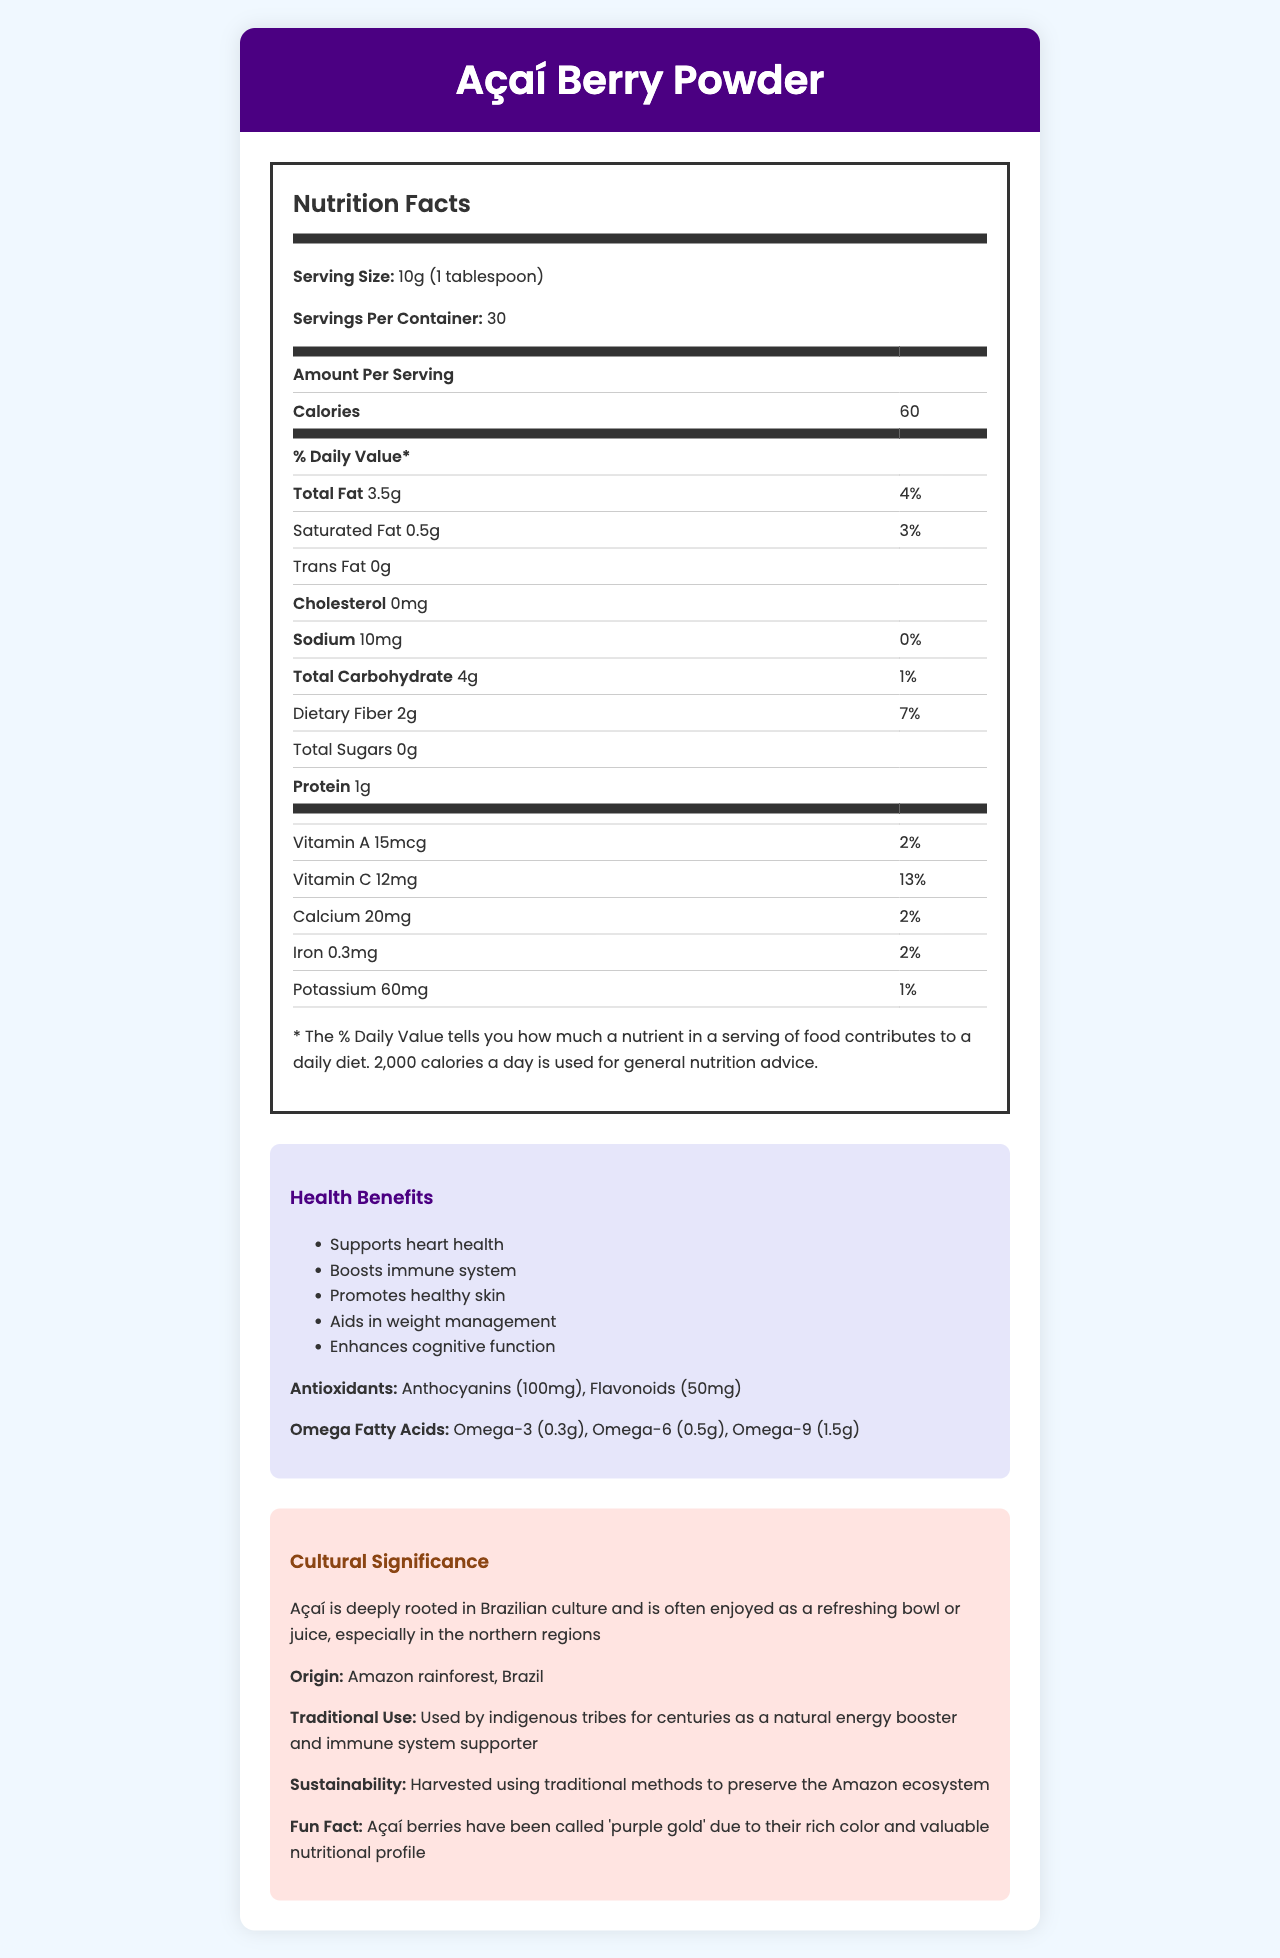what is the serving size of the Açaí Berry Powder? The serving size is clearly stated near the top of the nutrition facts section.
Answer: 10g (1 tablespoon) how many calories are in one serving of Açaí Berry Powder? The number of calories per serving is located in the middle of the nutrition facts section.
Answer: 60 calories which nutrient has the highest daily value percentage in the Açaí Berry Powder? In the vitamin section, Vitamin C has 13% daily value, which is the highest.
Answer: Vitamin C with 13% how much dietary fiber is there per serving and what is the daily value percentage? The dietary fiber content and its daily value percentage are listed under the total carbohydrate section.
Answer: 2g, 7% where is Açaí Berry Powder traditionally used? The origin of the product is stated in the cultural significance section.
Answer: Amazon rainforest, Brazil please list three health benefits of Açaí Berry Powder These health benefits are mentioned in the health benefits section.
Answer: Supports heart health, Boosts immune system, Promotes healthy skin which of the following is NOT a serving suggestion for Açaí Berry Powder? A. Add to smoothies B. Mix into yogurt C. Sprinkle on oatmeal D. Bake into bread The serving suggestions listed do not include baking into bread.
Answer: D how is Açaí Berry Powder harvested? A. Using traditional methods B. Mostly automated processes C. Imported from neighboring countries The sustainability section mentions that it is harvested using traditional methods.
Answer: A does Açaí Berry Powder contain any trans fat? The nutrition facts section clearly indicates that trans fat content is 0g.
Answer: No summarize the main idea of the document The document covers all these points, giving a well-rounded overview of Açaí Berry Powder.
Answer: The document provides detailed information on the nutritional content, health benefits, origin, traditional use, and cultural significance of Açaí Berry Powder. It emphasizes its high nutrient density, various health benefits, sustainability of its harvesting methods, and the ways it can be integrated into daily diets. how does Açaí Berry Powder contribute to weight management? The document lists aiding in weight management as a health benefit but does not explain the mechanism.
Answer: Not enough information what is one fun fact mentioned about Açaí berries? This fun fact is highlighted in the cultural significance section.
Answer: Açaí berries have been called 'purple gold' due to their rich color and valuable nutritional profile 